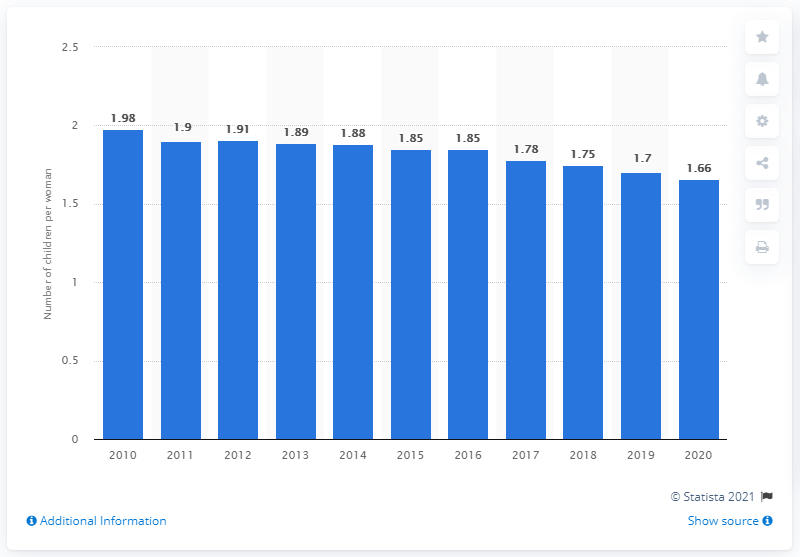Outline some significant characteristics in this image. In 2020, the fertility rate in Sweden was 1.66. 